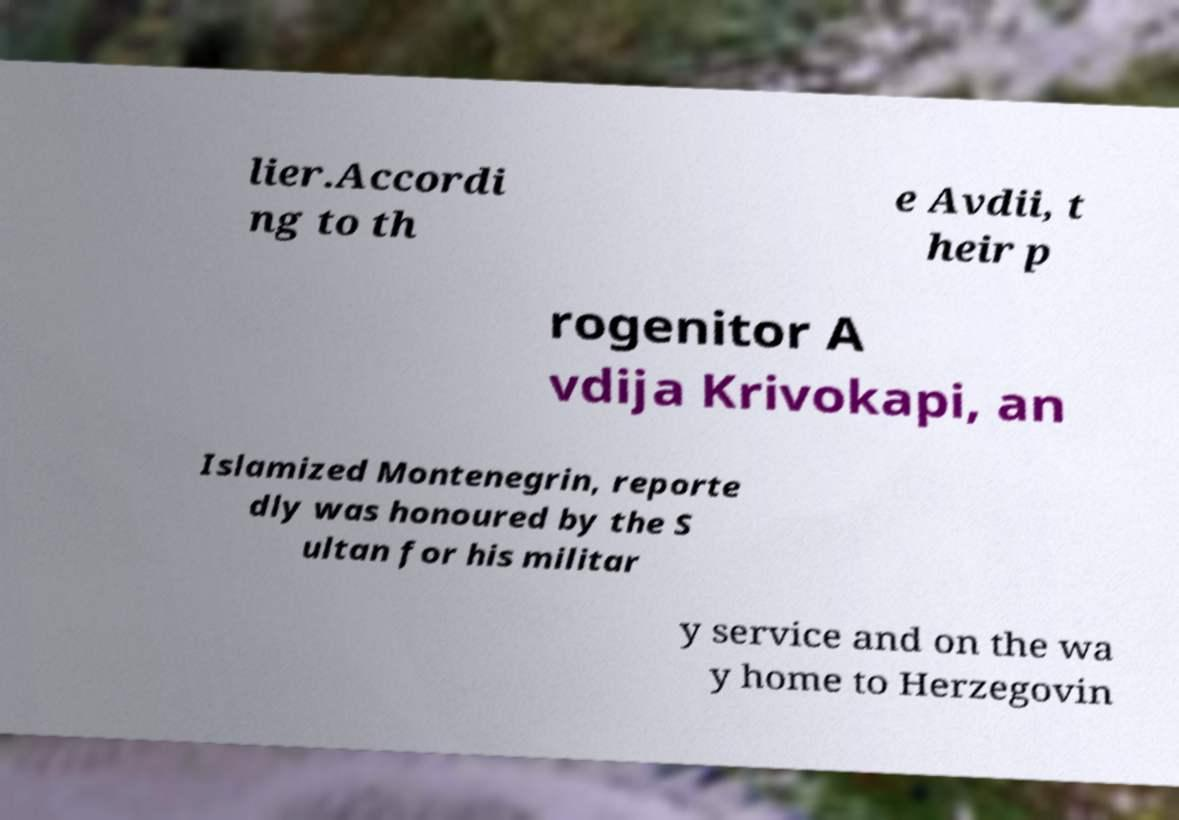Can you accurately transcribe the text from the provided image for me? lier.Accordi ng to th e Avdii, t heir p rogenitor A vdija Krivokapi, an Islamized Montenegrin, reporte dly was honoured by the S ultan for his militar y service and on the wa y home to Herzegovin 